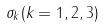<formula> <loc_0><loc_0><loc_500><loc_500>\sigma _ { k } ( k = 1 , 2 , 3 )</formula> 